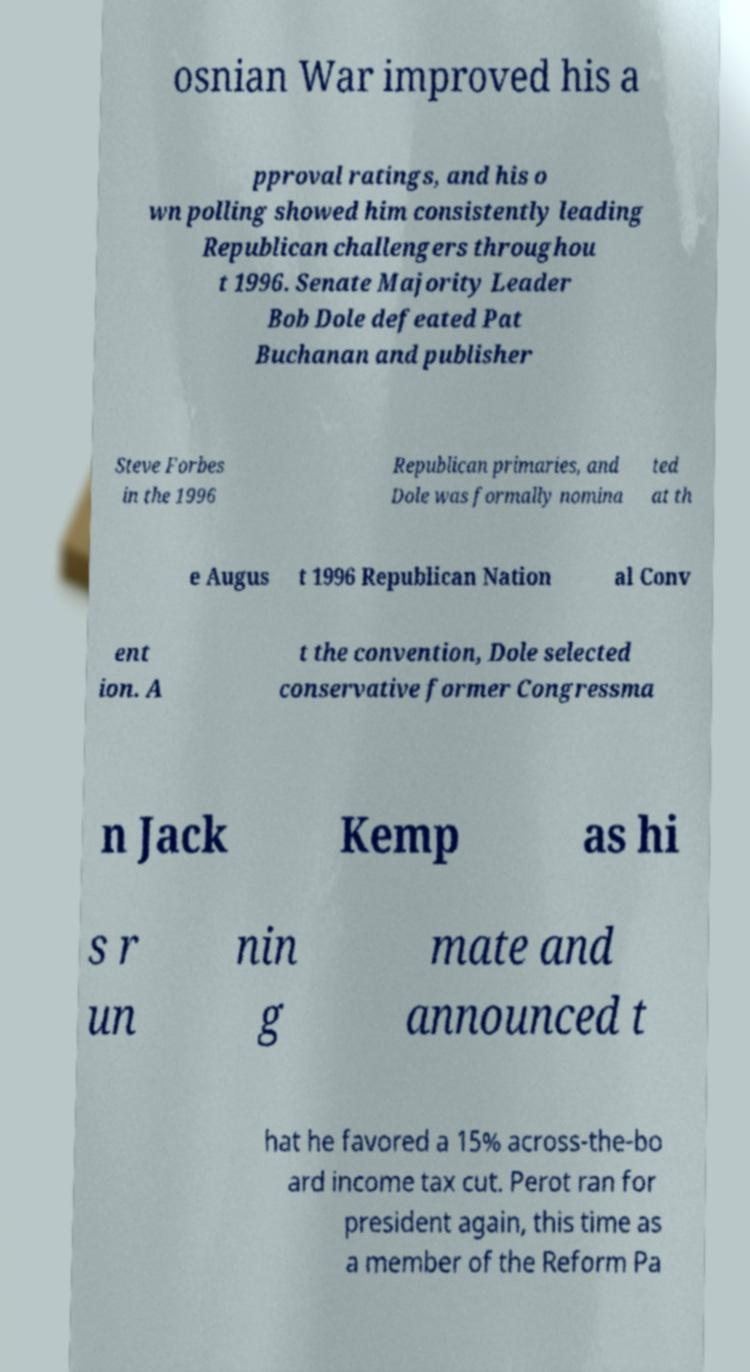Please identify and transcribe the text found in this image. osnian War improved his a pproval ratings, and his o wn polling showed him consistently leading Republican challengers throughou t 1996. Senate Majority Leader Bob Dole defeated Pat Buchanan and publisher Steve Forbes in the 1996 Republican primaries, and Dole was formally nomina ted at th e Augus t 1996 Republican Nation al Conv ent ion. A t the convention, Dole selected conservative former Congressma n Jack Kemp as hi s r un nin g mate and announced t hat he favored a 15% across-the-bo ard income tax cut. Perot ran for president again, this time as a member of the Reform Pa 